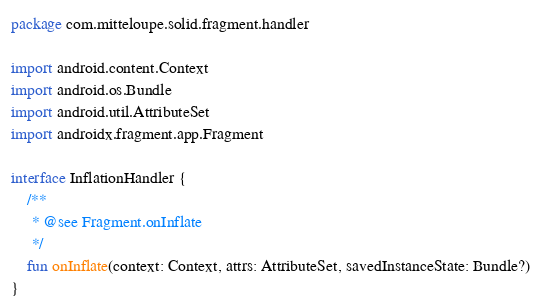Convert code to text. <code><loc_0><loc_0><loc_500><loc_500><_Kotlin_>package com.mitteloupe.solid.fragment.handler

import android.content.Context
import android.os.Bundle
import android.util.AttributeSet
import androidx.fragment.app.Fragment

interface InflationHandler {
    /**
     * @see Fragment.onInflate
     */
    fun onInflate(context: Context, attrs: AttributeSet, savedInstanceState: Bundle?)
}
</code> 